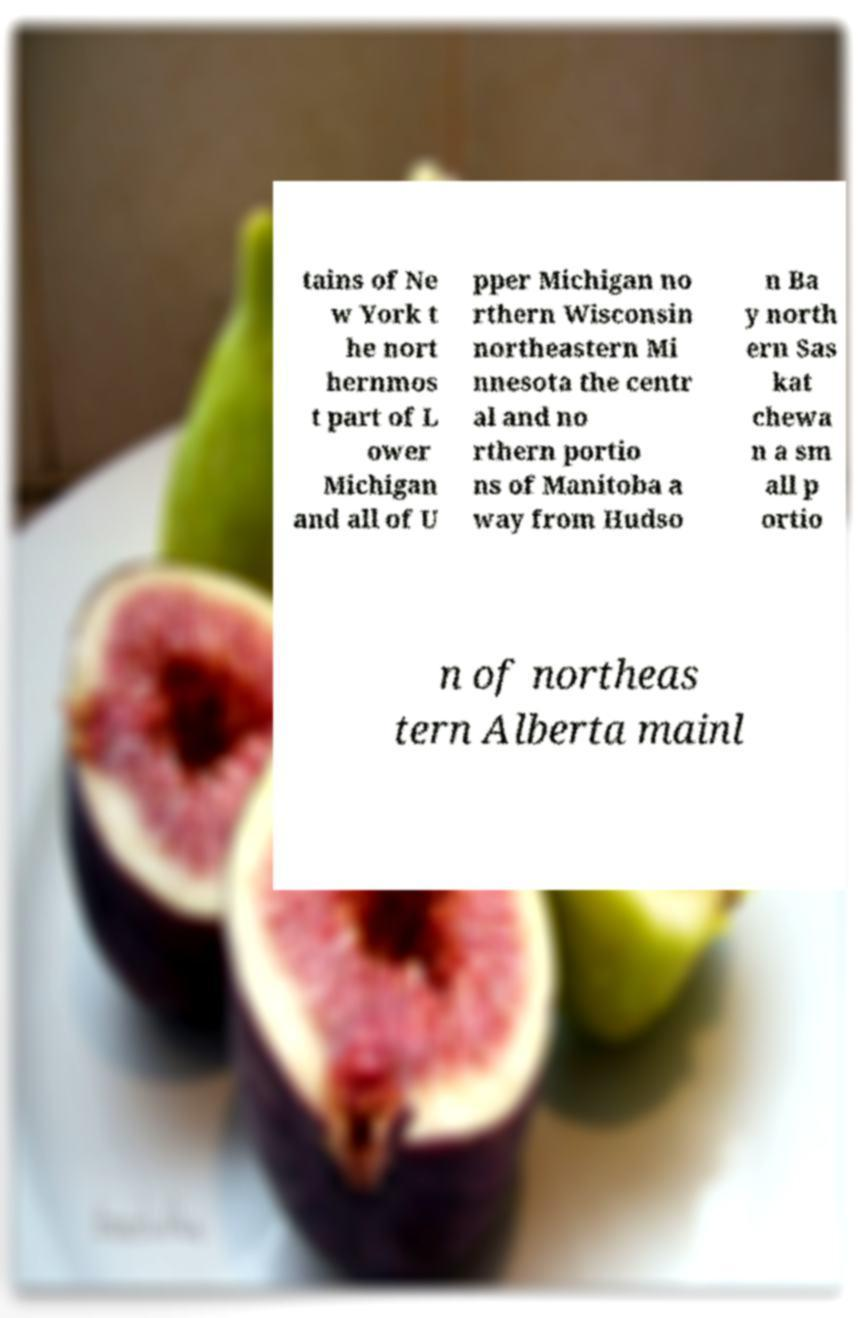Please read and relay the text visible in this image. What does it say? tains of Ne w York t he nort hernmos t part of L ower Michigan and all of U pper Michigan no rthern Wisconsin northeastern Mi nnesota the centr al and no rthern portio ns of Manitoba a way from Hudso n Ba y north ern Sas kat chewa n a sm all p ortio n of northeas tern Alberta mainl 